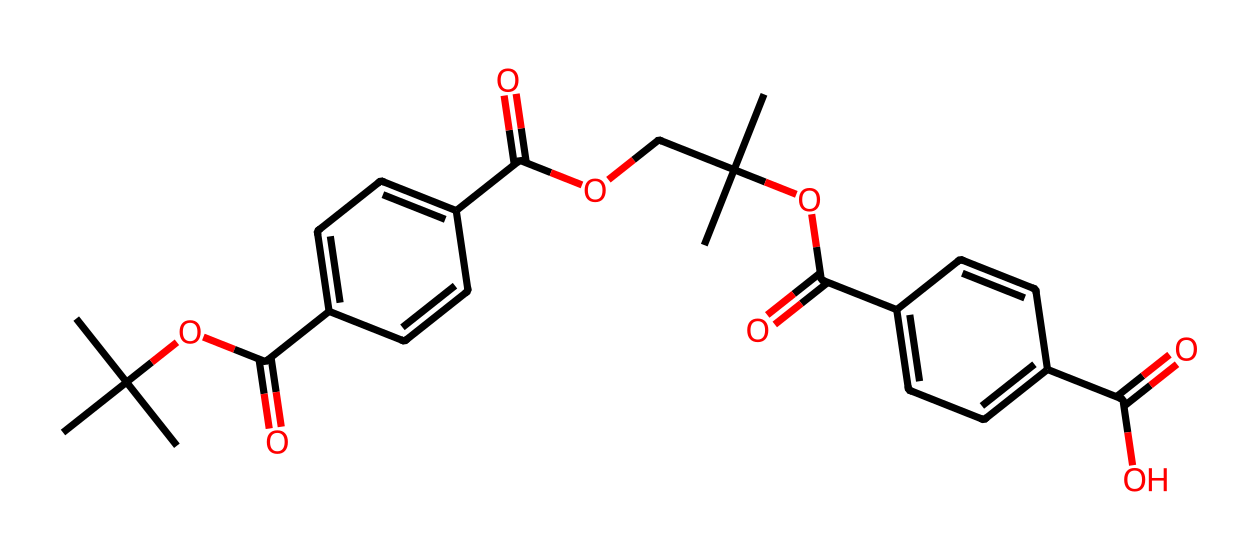What is the molecular formula of this compound? To find the molecular formula, we need to count the number of each type of atom in the SMILES representation. The structure shows there are 24 carbon atoms, 36 hydrogen atoms, 4 oxygen atoms. Therefore, the molecular formula is C24H36O4.
Answer: C24H36O4 How many aromatic rings are present in the structure? Analyzing the structure, we can identify two benzene rings based on the presence of two regions with alternating double bonds, characteristic of benzene.
Answer: 2 What type of polymer does this compound represent? This compound, due to its multiple repeating aromatic structures, indicates it is likely a polyester due to the presence of ester functional groups.
Answer: polyester What functional groups are evident in this chemical? The structure contains ester (–OC(=O)–) and carboxylic acid (–C(=O)O–) functional groups, identifiable by the specific arrangements of carbon, oxygen, and hydrogen atoms.
Answer: ester and carboxylic acid What is the total number of oxygen atoms present in this compound? By examining the chemical structure, we find there are four oxygen atoms represented, including those in both functional groups: esters and carboxylic acids.
Answer: 4 Which properties are likely enhanced in this compound due to its aromatic nature? The presence of aromatic rings in the structure usually provides enhanced thermal stability and chemical resistance, which are essential in lightweight vehicle components.
Answer: thermal stability and chemical resistance 